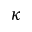<formula> <loc_0><loc_0><loc_500><loc_500>\kappa</formula> 